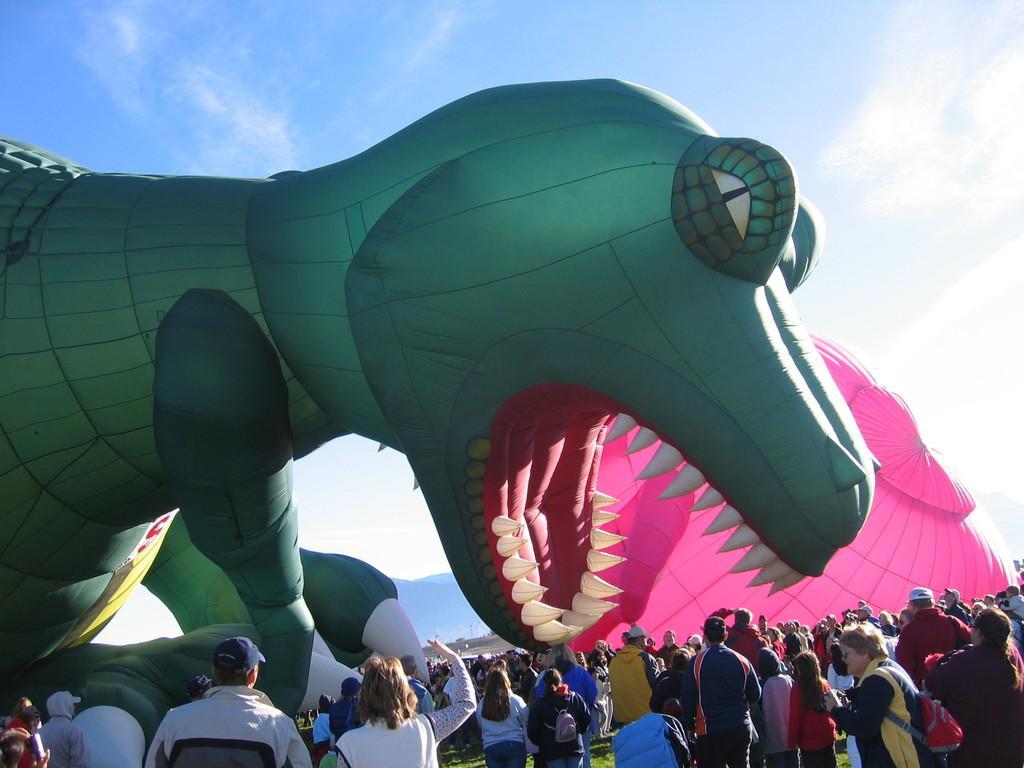Can you describe this image briefly? In the center of the image, we can see balloons and at the bottom, there are people. At the top, there is sky. 